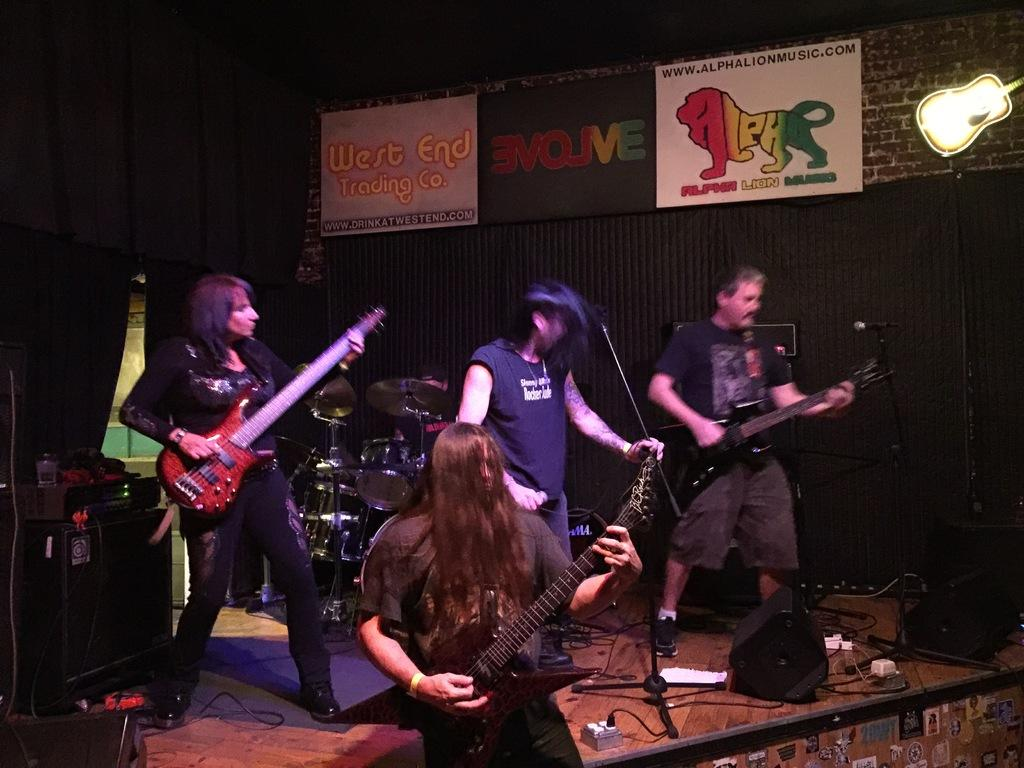How many people are on the stage in the image? There are three persons standing on a stage in the image. What are the three persons doing on the stage? The three persons are playing a guitar. Can you describe the person holding a microphone? One person is holding a microphone. What other objects can be seen in the image besides the people and the guitar? There are musical instruments and three posters on the wall in the image. What is the title of the book being read by the person on the stage? There is no book or reading activity depicted in the image; the three persons are playing a guitar. How far away is the distance between the two posters on the wall? The image does not provide any information about the distance between the posters on the wall, as it only mentions that there are three posters present. 